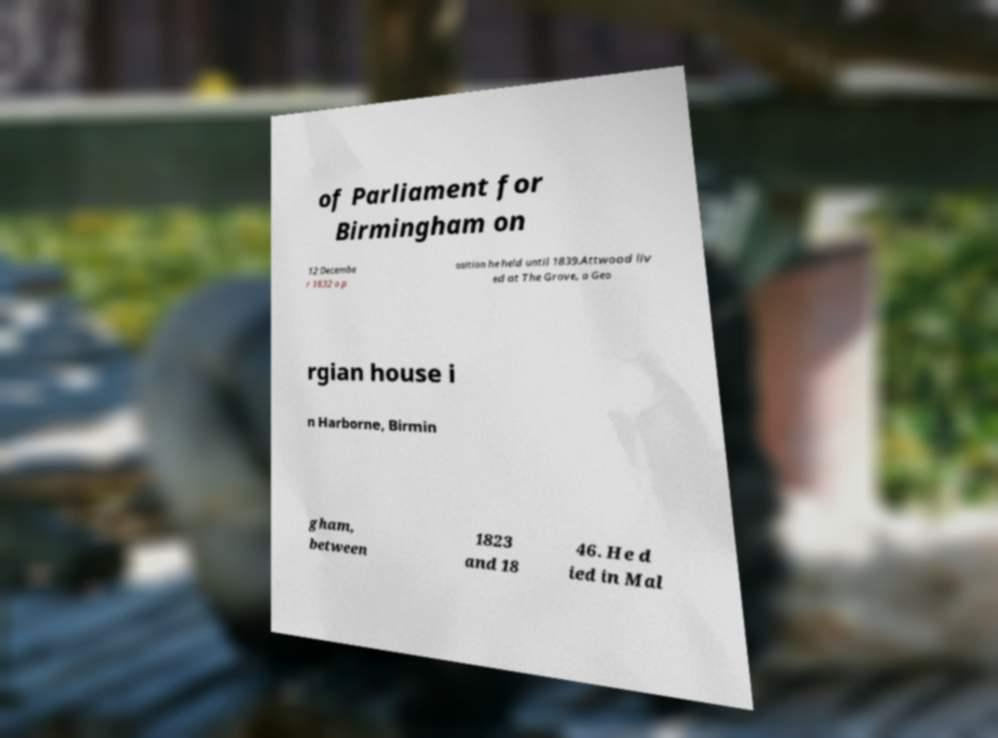I need the written content from this picture converted into text. Can you do that? of Parliament for Birmingham on 12 Decembe r 1832 a p osition he held until 1839.Attwood liv ed at The Grove, a Geo rgian house i n Harborne, Birmin gham, between 1823 and 18 46. He d ied in Mal 